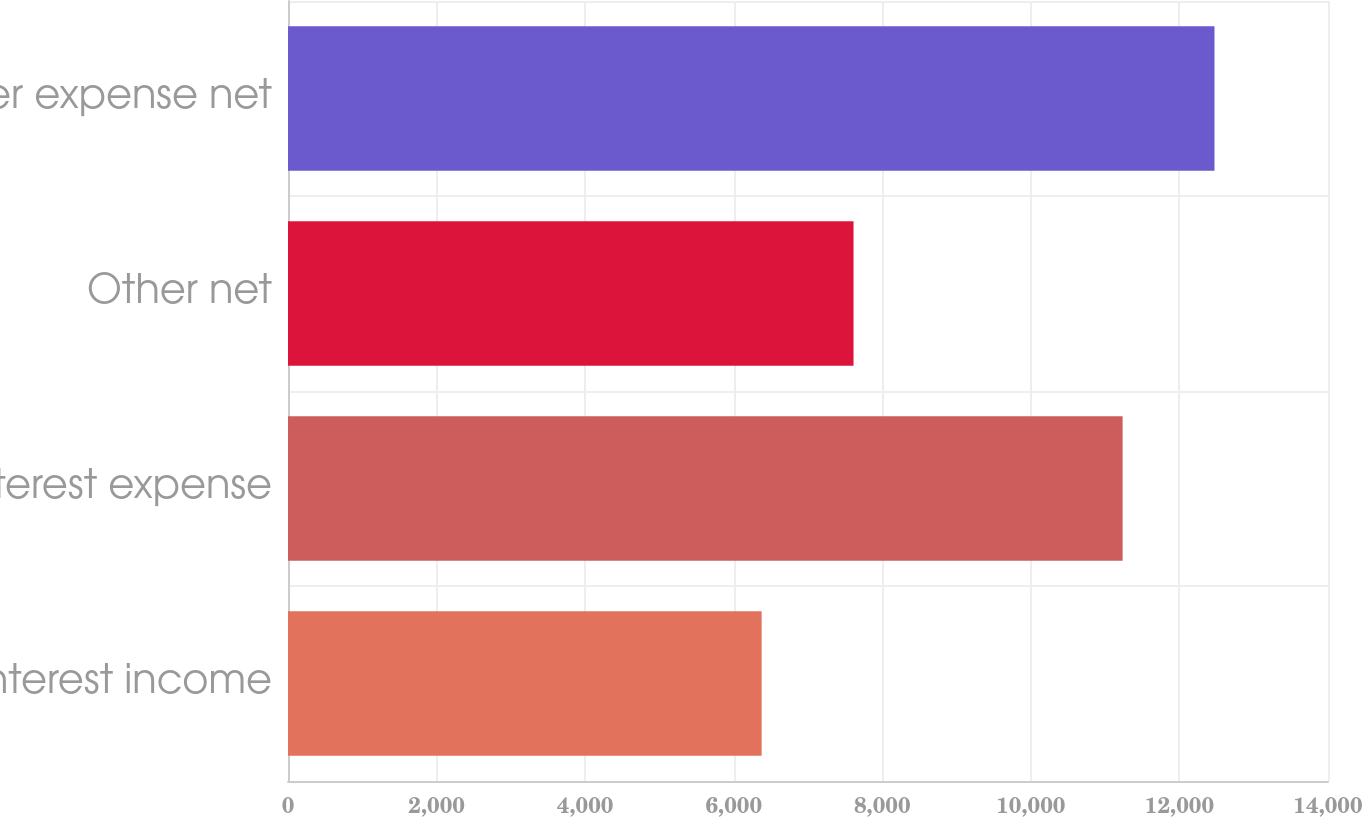<chart> <loc_0><loc_0><loc_500><loc_500><bar_chart><fcel>Interest income<fcel>Interest expense<fcel>Other net<fcel>Other expense net<nl><fcel>6376<fcel>11235<fcel>7613<fcel>12472<nl></chart> 